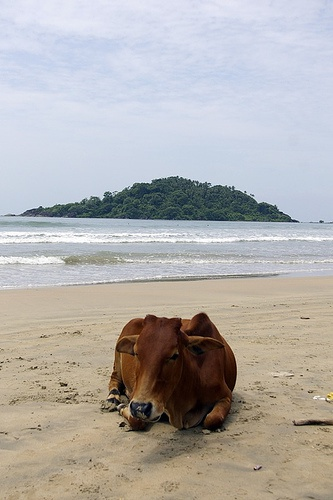Describe the objects in this image and their specific colors. I can see a cow in lavender, black, maroon, and brown tones in this image. 